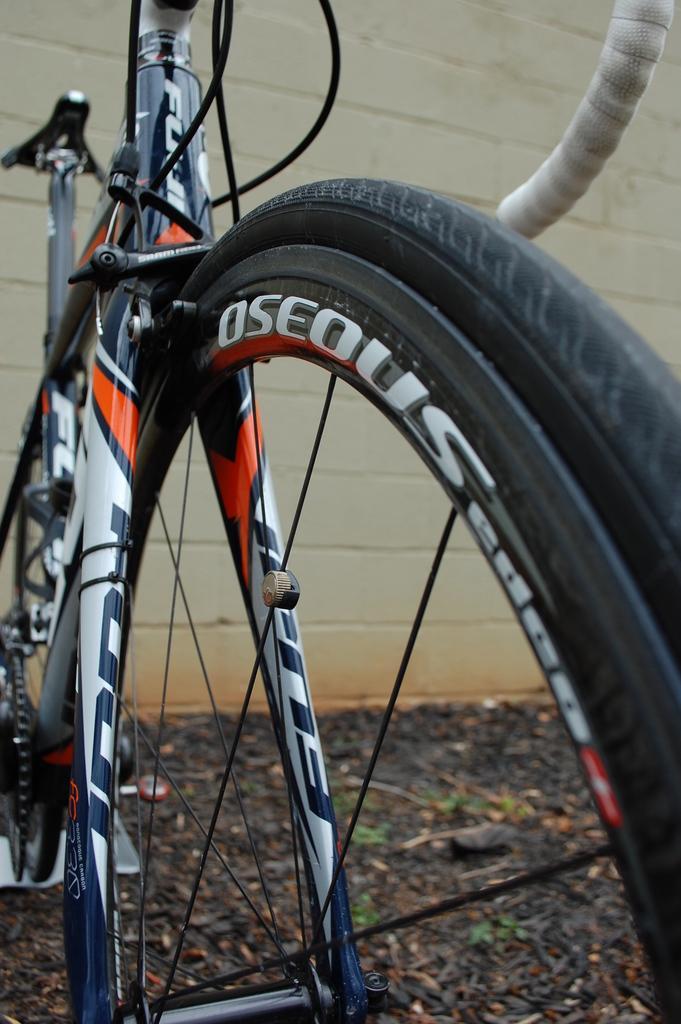Can you describe this image briefly? This image is a zoomed in picture of a bicycle. In the background of the image there is wall. 